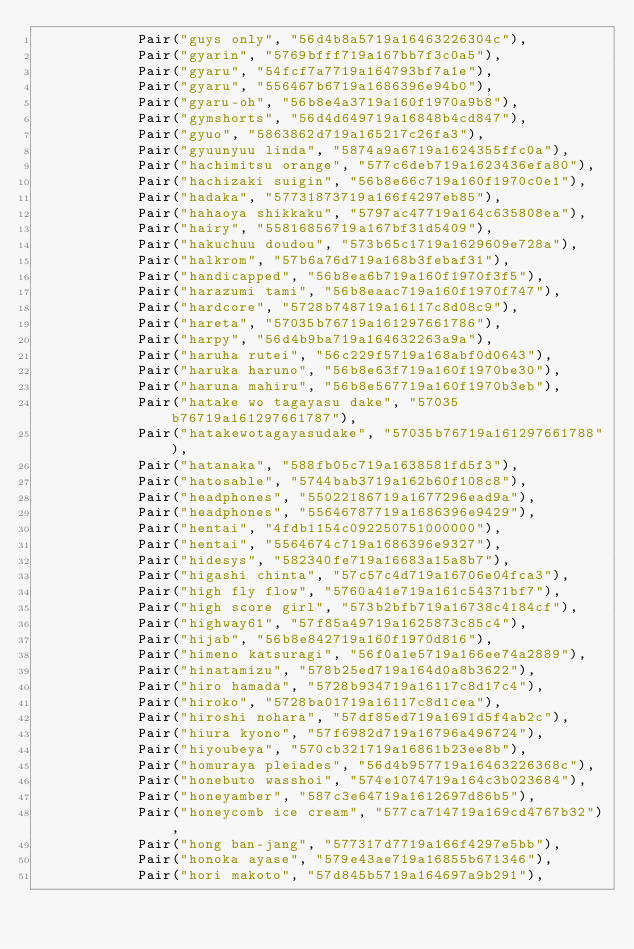Convert code to text. <code><loc_0><loc_0><loc_500><loc_500><_Kotlin_>            Pair("guys only", "56d4b8a5719a16463226304c"),
            Pair("gyarin", "5769bfff719a167bb7f3c0a5"),
            Pair("gyaru", "54fcf7a7719a164793bf7a1e"),
            Pair("gyaru", "556467b6719a1686396e94b0"),
            Pair("gyaru-oh", "56b8e4a3719a160f1970a9b8"),
            Pair("gymshorts", "56d4d649719a16848b4cd847"),
            Pair("gyuo", "5863862d719a165217c26fa3"),
            Pair("gyuunyuu linda", "5874a9a6719a1624355ffc0a"),
            Pair("hachimitsu orange", "577c6deb719a1623436efa80"),
            Pair("hachizaki suigin", "56b8e66c719a160f1970c0e1"),
            Pair("hadaka", "57731873719a166f4297eb85"),
            Pair("hahaoya shikkaku", "5797ac47719a164c635808ea"),
            Pair("hairy", "55816856719a167bf31d5409"),
            Pair("hakuchuu doudou", "573b65c1719a1629609e728a"),
            Pair("halkrom", "57b6a76d719a168b3febaf31"),
            Pair("handicapped", "56b8ea6b719a160f1970f3f5"),
            Pair("harazumi tami", "56b8eaac719a160f1970f747"),
            Pair("hardcore", "5728b748719a16117c8d08c9"),
            Pair("hareta", "57035b76719a161297661786"),
            Pair("harpy", "56d4b9ba719a164632263a9a"),
            Pair("haruha rutei", "56c229f5719a168abf0d0643"),
            Pair("haruka haruno", "56b8e63f719a160f1970be30"),
            Pair("haruna mahiru", "56b8e567719a160f1970b3eb"),
            Pair("hatake wo tagayasu dake", "57035b76719a161297661787"),
            Pair("hatakewotagayasudake", "57035b76719a161297661788"),
            Pair("hatanaka", "588fb05c719a1638581fd5f3"),
            Pair("hatosable", "5744bab3719a162b60f108c8"),
            Pair("headphones", "55022186719a1677296ead9a"),
            Pair("headphones", "55646787719a1686396e9429"),
            Pair("hentai", "4fdb1154c092250751000000"),
            Pair("hentai", "5564674c719a1686396e9327"),
            Pair("hidesys", "582340fe719a16683a15a8b7"),
            Pair("higashi chinta", "57c57c4d719a16706e04fca3"),
            Pair("high fly flow", "5760a41e719a161c54371bf7"),
            Pair("high score girl", "573b2bfb719a16738c4184cf"),
            Pair("highway61", "57f85a49719a1625873c85c4"),
            Pair("hijab", "56b8e842719a160f1970d816"),
            Pair("himeno katsuragi", "56f0a1e5719a166ee74a2889"),
            Pair("hinatamizu", "578b25ed719a164d0a8b3622"),
            Pair("hiro hamada", "5728b934719a16117c8d17c4"),
            Pair("hiroko", "5728ba01719a16117c8d1cea"),
            Pair("hiroshi nohara", "57df85ed719a1691d5f4ab2c"),
            Pair("hiura kyono", "57f6982d719a16796a496724"),
            Pair("hiyoubeya", "570cb321719a16861b23ee8b"),
            Pair("homuraya pleiades", "56d4b957719a16463226368c"),
            Pair("honebuto wasshoi", "574e1074719a164c3b023684"),
            Pair("honeyamber", "587c3e64719a1612697d86b5"),
            Pair("honeycomb ice cream", "577ca714719a169cd4767b32"),
            Pair("hong ban-jang", "577317d7719a166f4297e5bb"),
            Pair("honoka ayase", "579e43ae719a16855b671346"),
            Pair("hori makoto", "57d845b5719a164697a9b291"),</code> 